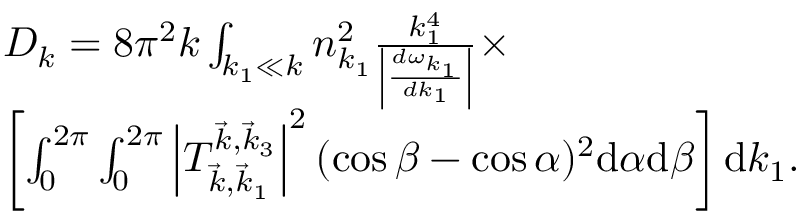Convert formula to latex. <formula><loc_0><loc_0><loc_500><loc_500>\begin{array} { r l } & { D _ { k } = 8 \pi ^ { 2 } k \int _ { k _ { 1 } \ll k } n _ { k _ { 1 } } ^ { 2 } \frac { k _ { 1 } ^ { 4 } } { \left | \frac { d \omega _ { k _ { 1 } } } { d k _ { 1 } } \right | } \times } \\ & { \left [ \int _ { 0 } ^ { 2 \pi } \int _ { 0 } ^ { 2 \pi } \left | T _ { \vec { k } , \vec { k } _ { 1 } } ^ { \vec { k } , \vec { k } _ { 3 } } \right | ^ { 2 } ( \cos \beta - \cos \alpha ) ^ { 2 } \mathrm d \alpha \mathrm d \beta \right ] \mathrm d k _ { 1 } . } \end{array}</formula> 